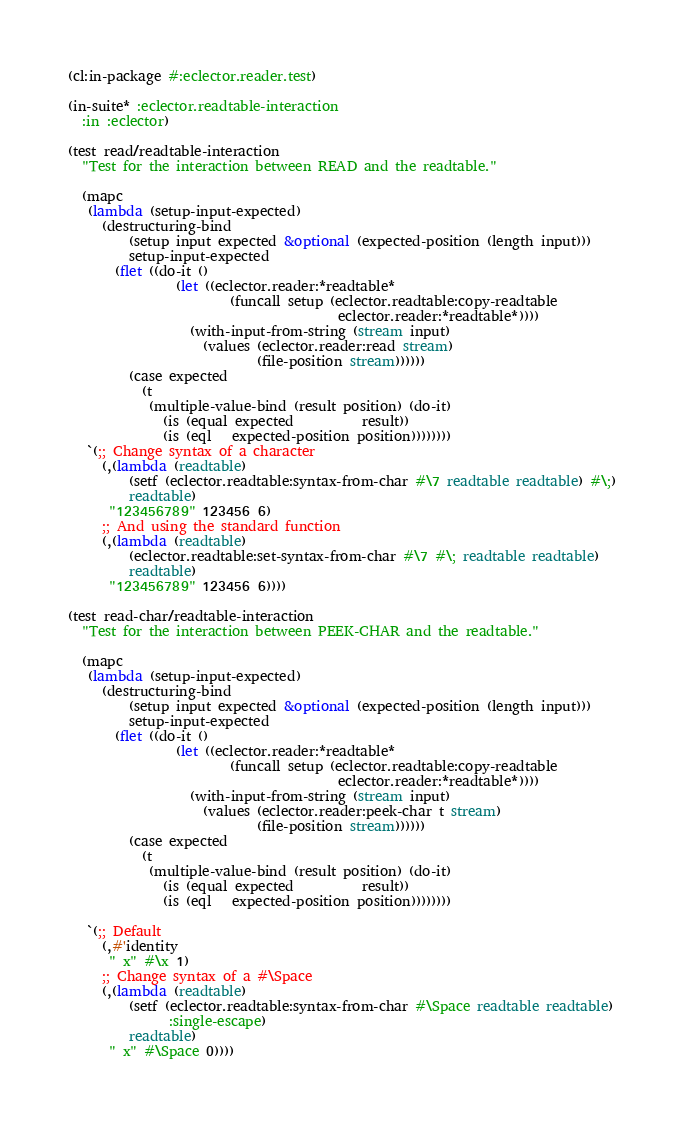Convert code to text. <code><loc_0><loc_0><loc_500><loc_500><_Lisp_>(cl:in-package #:eclector.reader.test)

(in-suite* :eclector.readtable-interaction
  :in :eclector)

(test read/readtable-interaction
  "Test for the interaction between READ and the readtable."

  (mapc
   (lambda (setup-input-expected)
     (destructuring-bind
         (setup input expected &optional (expected-position (length input)))
         setup-input-expected
       (flet ((do-it ()
                (let ((eclector.reader:*readtable*
                        (funcall setup (eclector.readtable:copy-readtable
                                        eclector.reader:*readtable*))))
                  (with-input-from-string (stream input)
                    (values (eclector.reader:read stream)
                            (file-position stream))))))
         (case expected
           (t
            (multiple-value-bind (result position) (do-it)
              (is (equal expected          result))
              (is (eql   expected-position position))))))))
   `(;; Change syntax of a character
     (,(lambda (readtable)
         (setf (eclector.readtable:syntax-from-char #\7 readtable readtable) #\;)
         readtable)
      "123456789" 123456 6)
     ;; And using the standard function
     (,(lambda (readtable)
         (eclector.readtable:set-syntax-from-char #\7 #\; readtable readtable)
         readtable)
      "123456789" 123456 6))))

(test read-char/readtable-interaction
  "Test for the interaction between PEEK-CHAR and the readtable."

  (mapc
   (lambda (setup-input-expected)
     (destructuring-bind
         (setup input expected &optional (expected-position (length input)))
         setup-input-expected
       (flet ((do-it ()
                (let ((eclector.reader:*readtable*
                        (funcall setup (eclector.readtable:copy-readtable
                                        eclector.reader:*readtable*))))
                  (with-input-from-string (stream input)
                    (values (eclector.reader:peek-char t stream)
                            (file-position stream))))))
         (case expected
           (t
            (multiple-value-bind (result position) (do-it)
              (is (equal expected          result))
              (is (eql   expected-position position))))))))

   `(;; Default
     (,#'identity
      " x" #\x 1)
     ;; Change syntax of a #\Space
     (,(lambda (readtable)
         (setf (eclector.readtable:syntax-from-char #\Space readtable readtable)
               :single-escape)
         readtable)
      " x" #\Space 0))))
</code> 